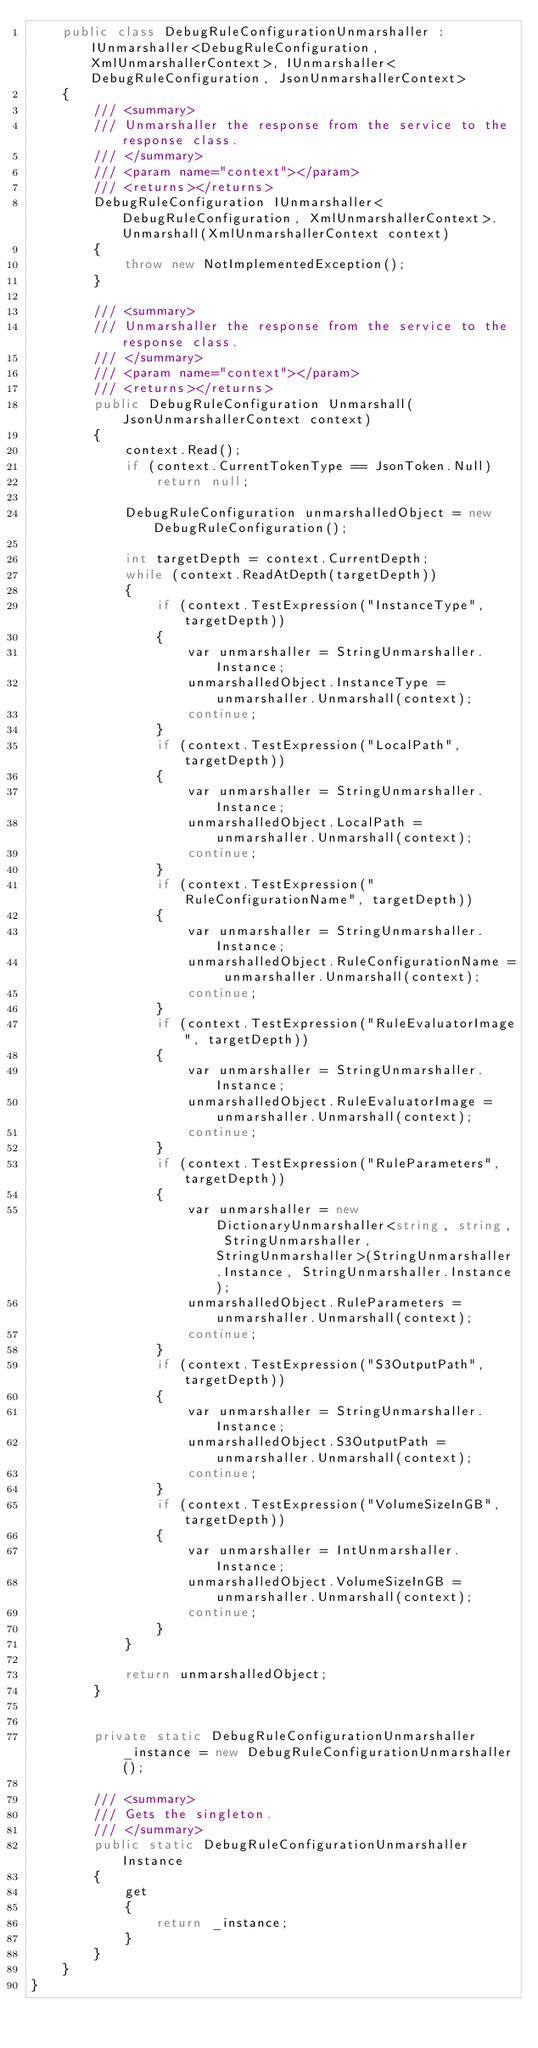<code> <loc_0><loc_0><loc_500><loc_500><_C#_>    public class DebugRuleConfigurationUnmarshaller : IUnmarshaller<DebugRuleConfiguration, XmlUnmarshallerContext>, IUnmarshaller<DebugRuleConfiguration, JsonUnmarshallerContext>
    {
        /// <summary>
        /// Unmarshaller the response from the service to the response class.
        /// </summary>  
        /// <param name="context"></param>
        /// <returns></returns>
        DebugRuleConfiguration IUnmarshaller<DebugRuleConfiguration, XmlUnmarshallerContext>.Unmarshall(XmlUnmarshallerContext context)
        {
            throw new NotImplementedException();
        }

        /// <summary>
        /// Unmarshaller the response from the service to the response class.
        /// </summary>  
        /// <param name="context"></param>
        /// <returns></returns>
        public DebugRuleConfiguration Unmarshall(JsonUnmarshallerContext context)
        {
            context.Read();
            if (context.CurrentTokenType == JsonToken.Null) 
                return null;

            DebugRuleConfiguration unmarshalledObject = new DebugRuleConfiguration();
        
            int targetDepth = context.CurrentDepth;
            while (context.ReadAtDepth(targetDepth))
            {
                if (context.TestExpression("InstanceType", targetDepth))
                {
                    var unmarshaller = StringUnmarshaller.Instance;
                    unmarshalledObject.InstanceType = unmarshaller.Unmarshall(context);
                    continue;
                }
                if (context.TestExpression("LocalPath", targetDepth))
                {
                    var unmarshaller = StringUnmarshaller.Instance;
                    unmarshalledObject.LocalPath = unmarshaller.Unmarshall(context);
                    continue;
                }
                if (context.TestExpression("RuleConfigurationName", targetDepth))
                {
                    var unmarshaller = StringUnmarshaller.Instance;
                    unmarshalledObject.RuleConfigurationName = unmarshaller.Unmarshall(context);
                    continue;
                }
                if (context.TestExpression("RuleEvaluatorImage", targetDepth))
                {
                    var unmarshaller = StringUnmarshaller.Instance;
                    unmarshalledObject.RuleEvaluatorImage = unmarshaller.Unmarshall(context);
                    continue;
                }
                if (context.TestExpression("RuleParameters", targetDepth))
                {
                    var unmarshaller = new DictionaryUnmarshaller<string, string, StringUnmarshaller, StringUnmarshaller>(StringUnmarshaller.Instance, StringUnmarshaller.Instance);
                    unmarshalledObject.RuleParameters = unmarshaller.Unmarshall(context);
                    continue;
                }
                if (context.TestExpression("S3OutputPath", targetDepth))
                {
                    var unmarshaller = StringUnmarshaller.Instance;
                    unmarshalledObject.S3OutputPath = unmarshaller.Unmarshall(context);
                    continue;
                }
                if (context.TestExpression("VolumeSizeInGB", targetDepth))
                {
                    var unmarshaller = IntUnmarshaller.Instance;
                    unmarshalledObject.VolumeSizeInGB = unmarshaller.Unmarshall(context);
                    continue;
                }
            }
          
            return unmarshalledObject;
        }


        private static DebugRuleConfigurationUnmarshaller _instance = new DebugRuleConfigurationUnmarshaller();        

        /// <summary>
        /// Gets the singleton.
        /// </summary>  
        public static DebugRuleConfigurationUnmarshaller Instance
        {
            get
            {
                return _instance;
            }
        }
    }
}</code> 